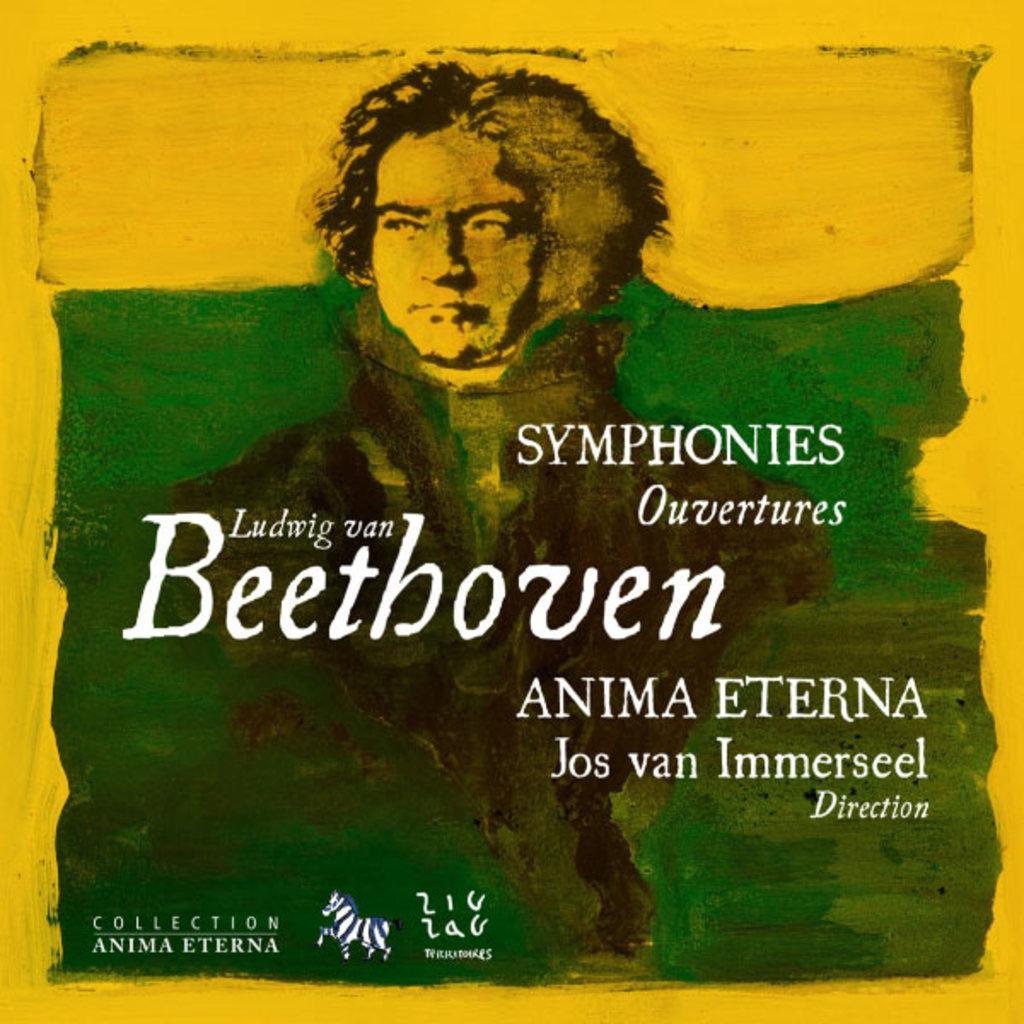Can you describe this image briefly? There is a poster. On which, there is a painting of a person. On which, there are texts and watermark. The background is yellow in color. 